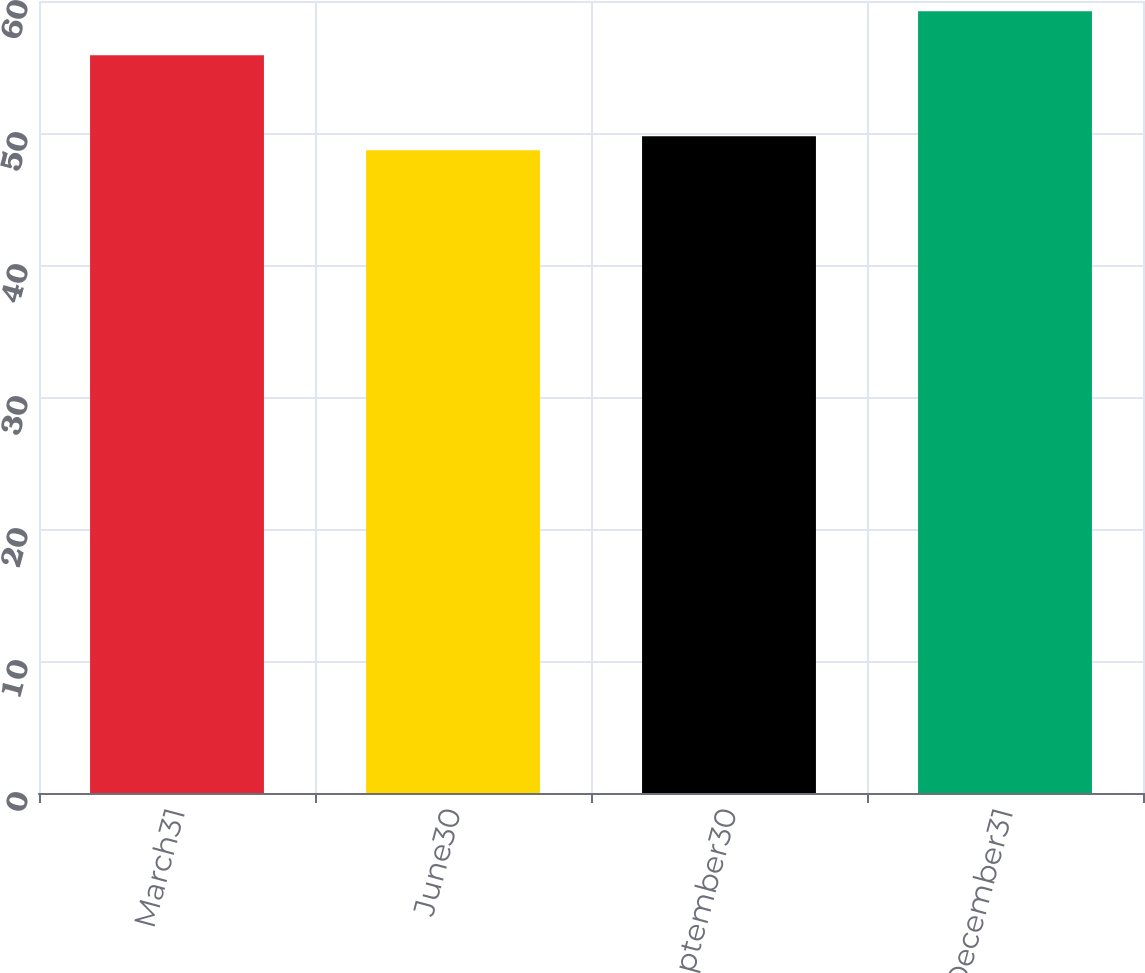<chart> <loc_0><loc_0><loc_500><loc_500><bar_chart><fcel>March31<fcel>June30<fcel>September30<fcel>December31<nl><fcel>55.89<fcel>48.7<fcel>49.75<fcel>59.23<nl></chart> 